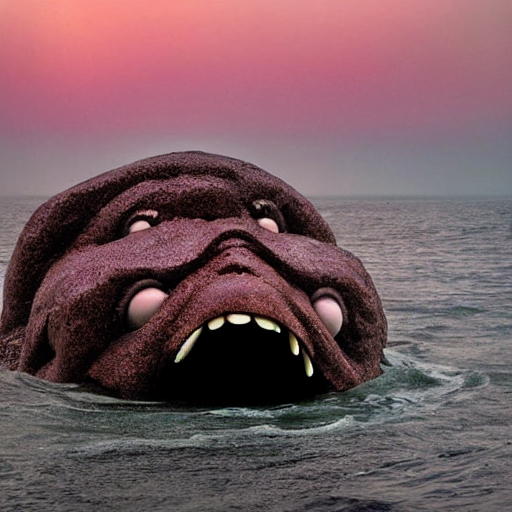Can you describe the mood of the image? The image conveys a mood of eerie calmness infused with a sense of otherworldliness. The subdued lighting and the mellow color palette of the sky contrast with the enigmatic emergence of the creature, creating a juxtaposition that is both tranquil and unsettling. It invites viewers to ponder the narrative and the emotions it aims to evoke. How does the use of color contribute to the mood? The use of warm and soft hues in the sky gives the scene a serene backdrop, which contrasts with the creature's dark, textured surface. This interplay of warmth against the stark, cool darkness of the creature reinforces the enigmatic quality and could suggest a symbolic duality of light and dark, known and unknown. 